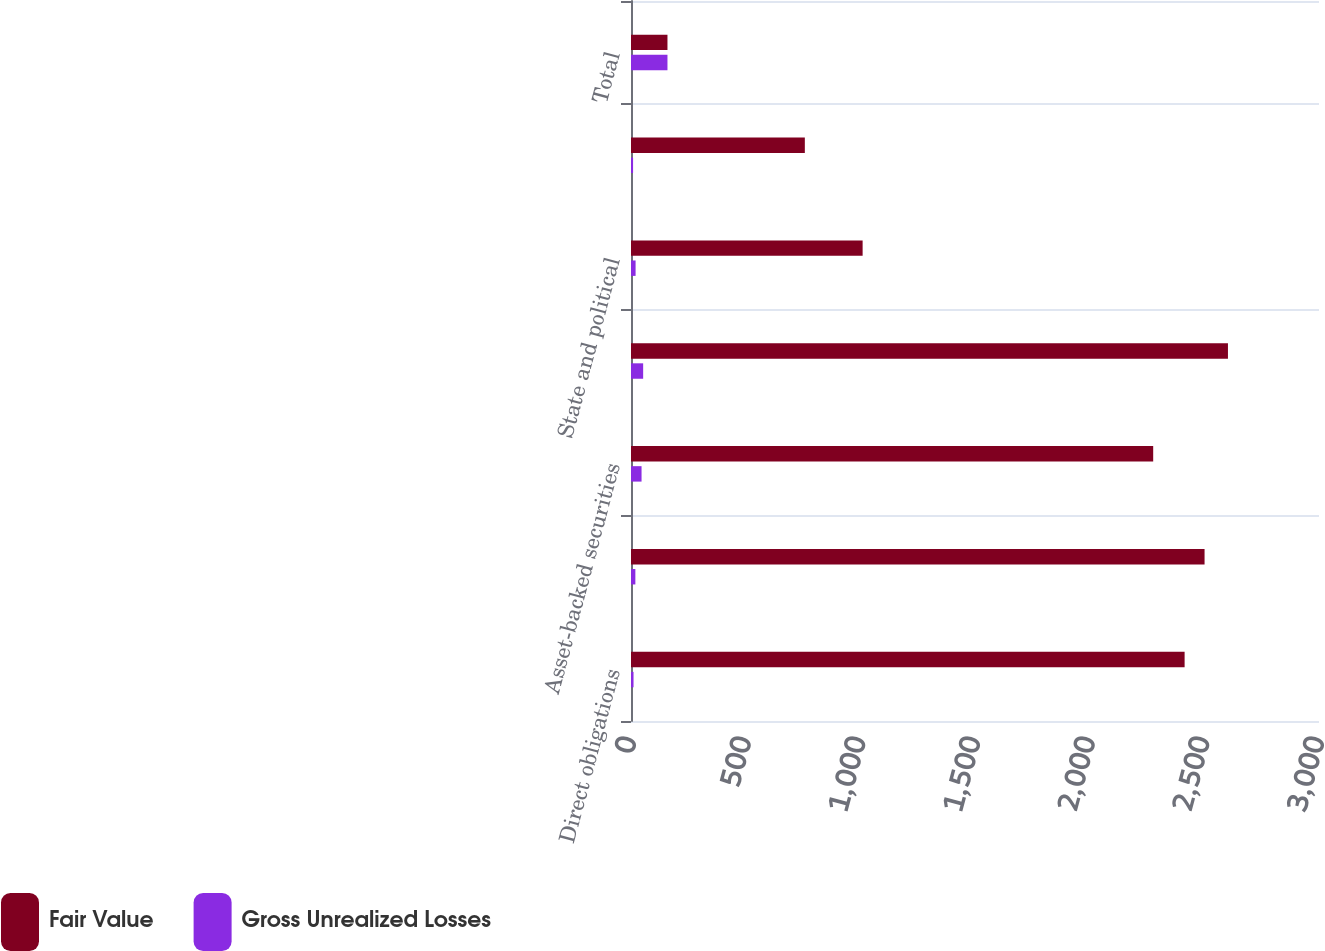Convert chart to OTSL. <chart><loc_0><loc_0><loc_500><loc_500><stacked_bar_chart><ecel><fcel>Direct obligations<fcel>Mortgage-backed securities<fcel>Asset-backed securities<fcel>Collateralized mortgage<fcel>State and political<fcel>Other debt investments<fcel>Total<nl><fcel>Fair Value<fcel>2414<fcel>2501<fcel>2277<fcel>2603<fcel>1010<fcel>758<fcel>159<nl><fcel>Gross Unrealized Losses<fcel>11<fcel>19<fcel>46<fcel>53<fcel>20<fcel>9<fcel>159<nl></chart> 